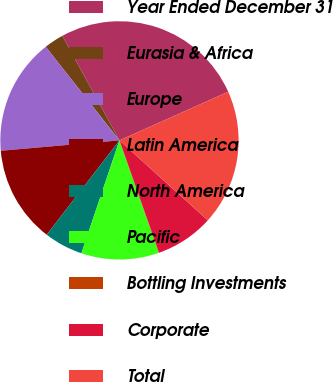Convert chart. <chart><loc_0><loc_0><loc_500><loc_500><pie_chart><fcel>Year Ended December 31<fcel>Eurasia & Africa<fcel>Europe<fcel>Latin America<fcel>North America<fcel>Pacific<fcel>Bottling Investments<fcel>Corporate<fcel>Total<nl><fcel>26.27%<fcel>2.66%<fcel>15.77%<fcel>13.15%<fcel>5.28%<fcel>10.53%<fcel>0.04%<fcel>7.9%<fcel>18.4%<nl></chart> 